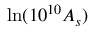Convert formula to latex. <formula><loc_0><loc_0><loc_500><loc_500>\ln ( 1 0 ^ { 1 0 } A _ { s } )</formula> 